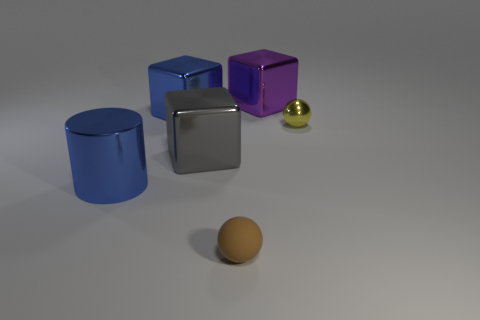Subtract all blue metal blocks. How many blocks are left? 2 Subtract all brown balls. How many balls are left? 1 Subtract all cylinders. How many objects are left? 5 Subtract all cyan spheres. How many blue blocks are left? 1 Subtract all small brown rubber balls. Subtract all big cubes. How many objects are left? 2 Add 6 brown things. How many brown things are left? 7 Add 6 big green matte cubes. How many big green matte cubes exist? 6 Add 4 large metallic objects. How many objects exist? 10 Subtract 0 yellow blocks. How many objects are left? 6 Subtract 2 spheres. How many spheres are left? 0 